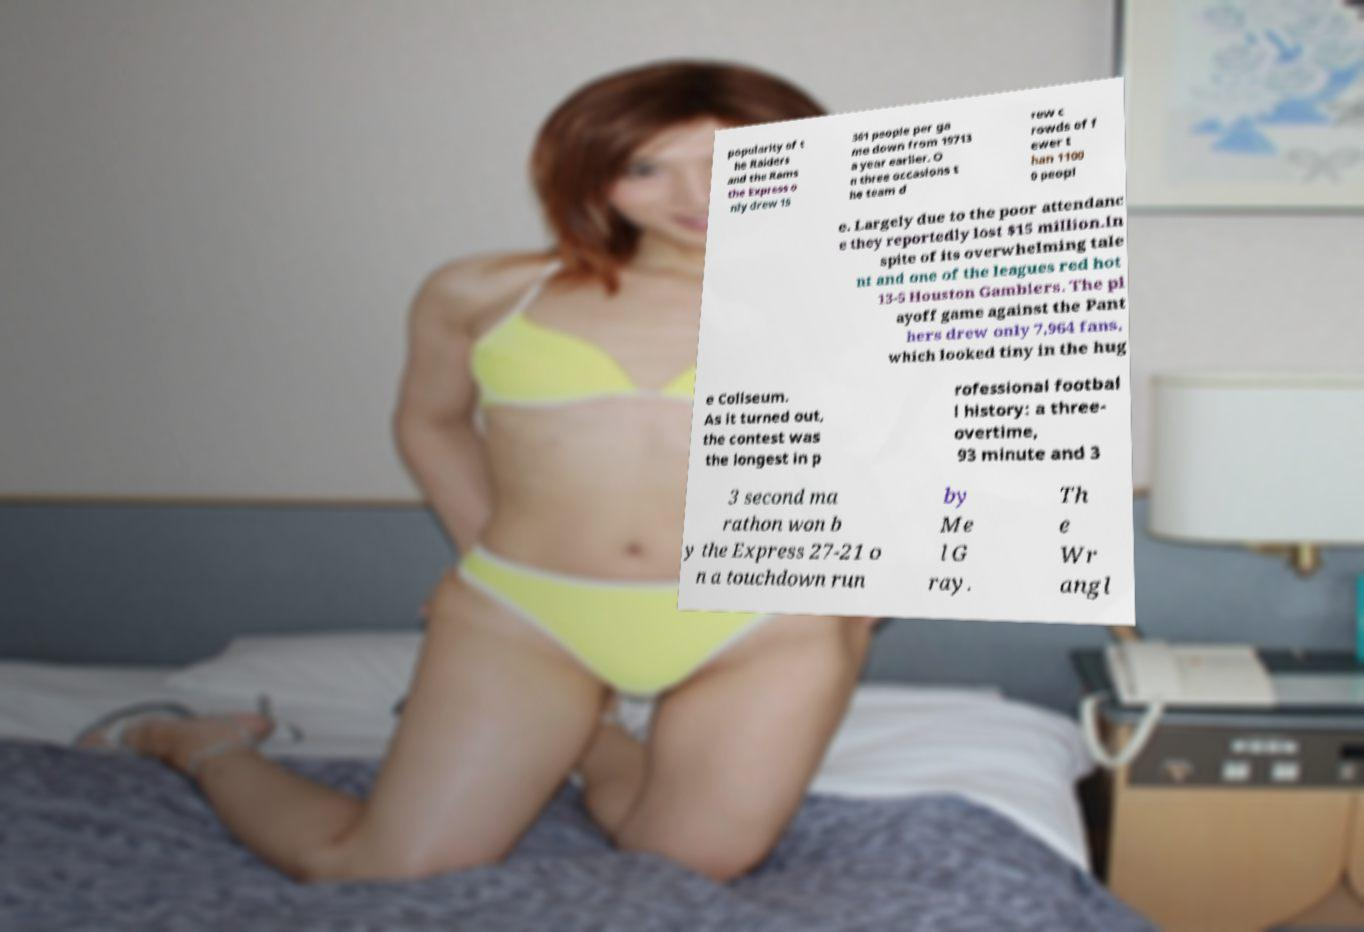Please identify and transcribe the text found in this image. popularity of t he Raiders and the Rams the Express o nly drew 15 361 people per ga me down from 19713 a year earlier. O n three occasions t he team d rew c rowds of f ewer t han 1100 0 peopl e. Largely due to the poor attendanc e they reportedly lost $15 million.In spite of its overwhelming tale nt and one of the leagues red hot 13-5 Houston Gamblers. The pl ayoff game against the Pant hers drew only 7,964 fans, which looked tiny in the hug e Coliseum. As it turned out, the contest was the longest in p rofessional footbal l history: a three- overtime, 93 minute and 3 3 second ma rathon won b y the Express 27-21 o n a touchdown run by Me l G ray. Th e Wr angl 